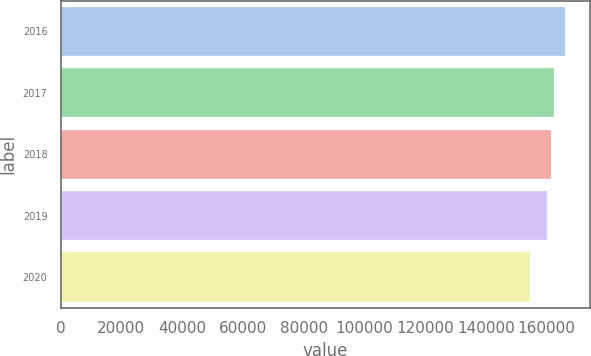Convert chart to OTSL. <chart><loc_0><loc_0><loc_500><loc_500><bar_chart><fcel>2016<fcel>2017<fcel>2018<fcel>2019<fcel>2020<nl><fcel>165903<fcel>162554<fcel>161416<fcel>160058<fcel>154519<nl></chart> 